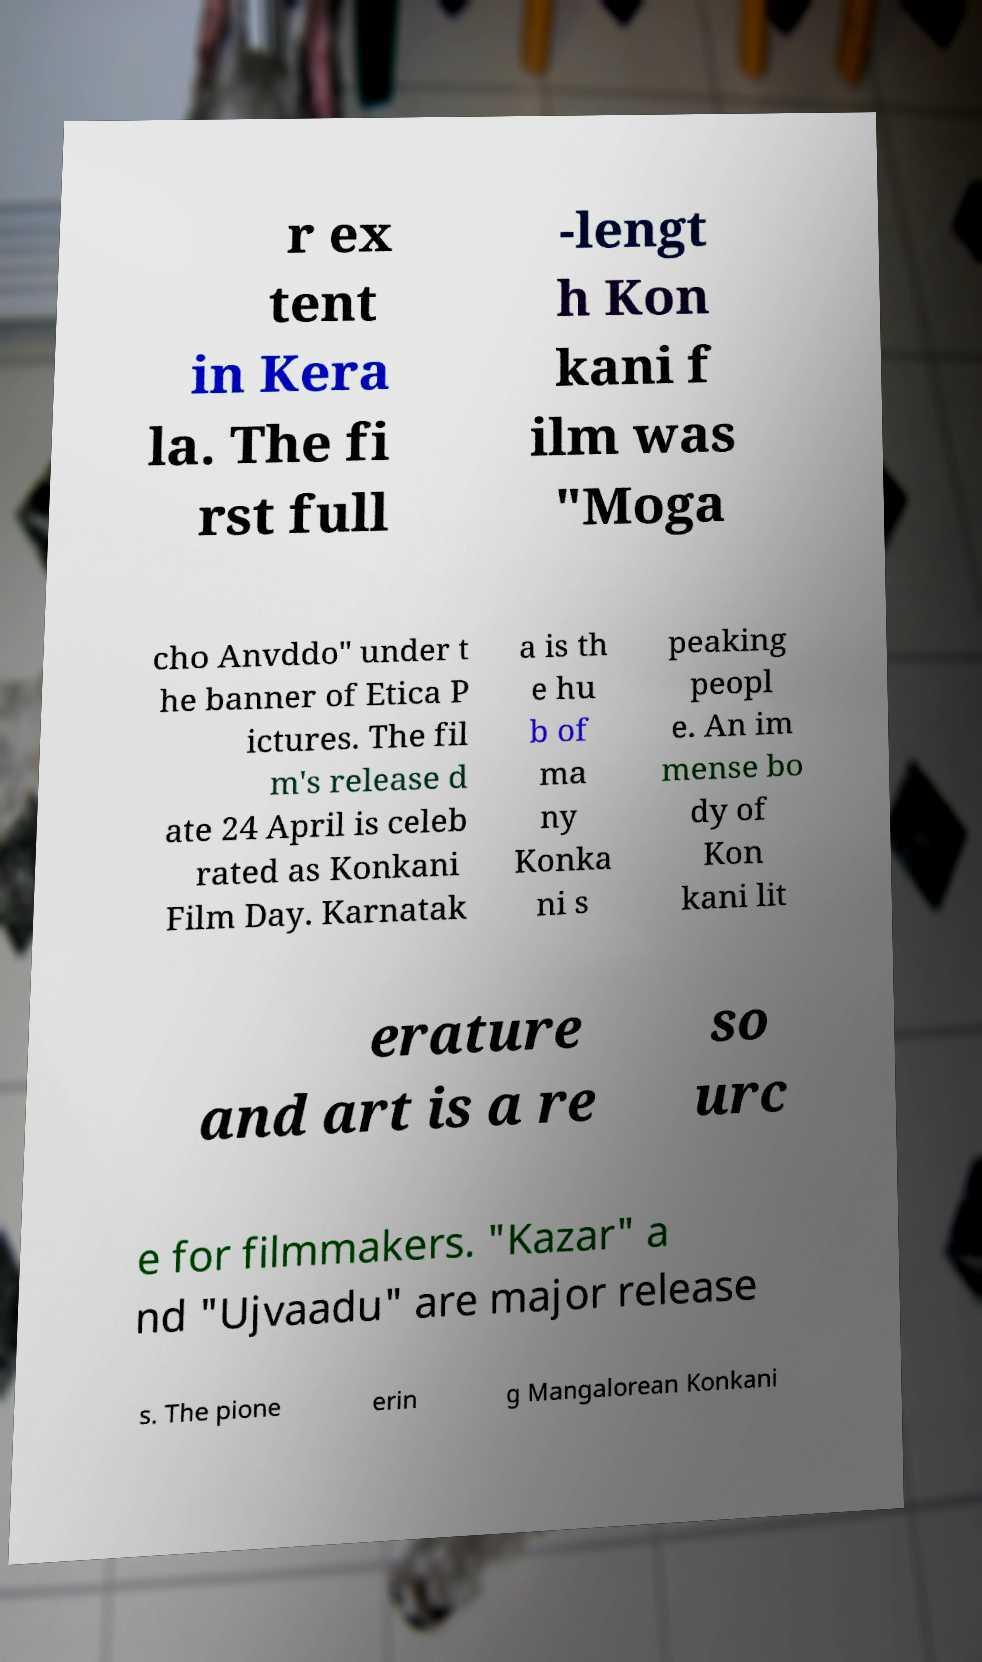Please read and relay the text visible in this image. What does it say? r ex tent in Kera la. The fi rst full -lengt h Kon kani f ilm was "Moga cho Anvddo" under t he banner of Etica P ictures. The fil m's release d ate 24 April is celeb rated as Konkani Film Day. Karnatak a is th e hu b of ma ny Konka ni s peaking peopl e. An im mense bo dy of Kon kani lit erature and art is a re so urc e for filmmakers. "Kazar" a nd "Ujvaadu" are major release s. The pione erin g Mangalorean Konkani 